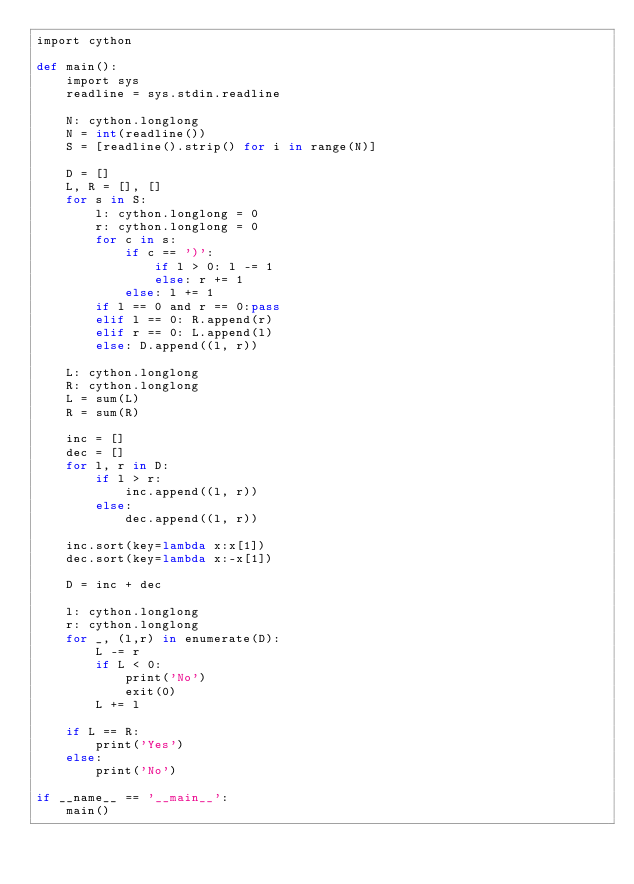Convert code to text. <code><loc_0><loc_0><loc_500><loc_500><_Cython_>import cython
 
def main():
    import sys
    readline = sys.stdin.readline
    
    N: cython.longlong
    N = int(readline())
    S = [readline().strip() for i in range(N)]
    
    D = []
    L, R = [], []
    for s in S:
        l: cython.longlong = 0
        r: cython.longlong = 0
        for c in s:
            if c == ')':
                if l > 0: l -= 1
                else: r += 1
            else: l += 1
        if l == 0 and r == 0:pass
        elif l == 0: R.append(r)
        elif r == 0: L.append(l)
        else: D.append((l, r))
    
    L: cython.longlong
    R: cython.longlong
    L = sum(L)
    R = sum(R)
    
    inc = []
    dec = []
    for l, r in D:
        if l > r:
            inc.append((l, r))
        else:
            dec.append((l, r))
    
    inc.sort(key=lambda x:x[1])
    dec.sort(key=lambda x:-x[1])
    
    D = inc + dec
    
    l: cython.longlong
    r: cython.longlong
    for _, (l,r) in enumerate(D):
        L -= r
        if L < 0:
            print('No')
            exit(0)
        L += l
    
    if L == R:
        print('Yes')
    else:
        print('No')
 
if __name__ == '__main__':
    main()</code> 